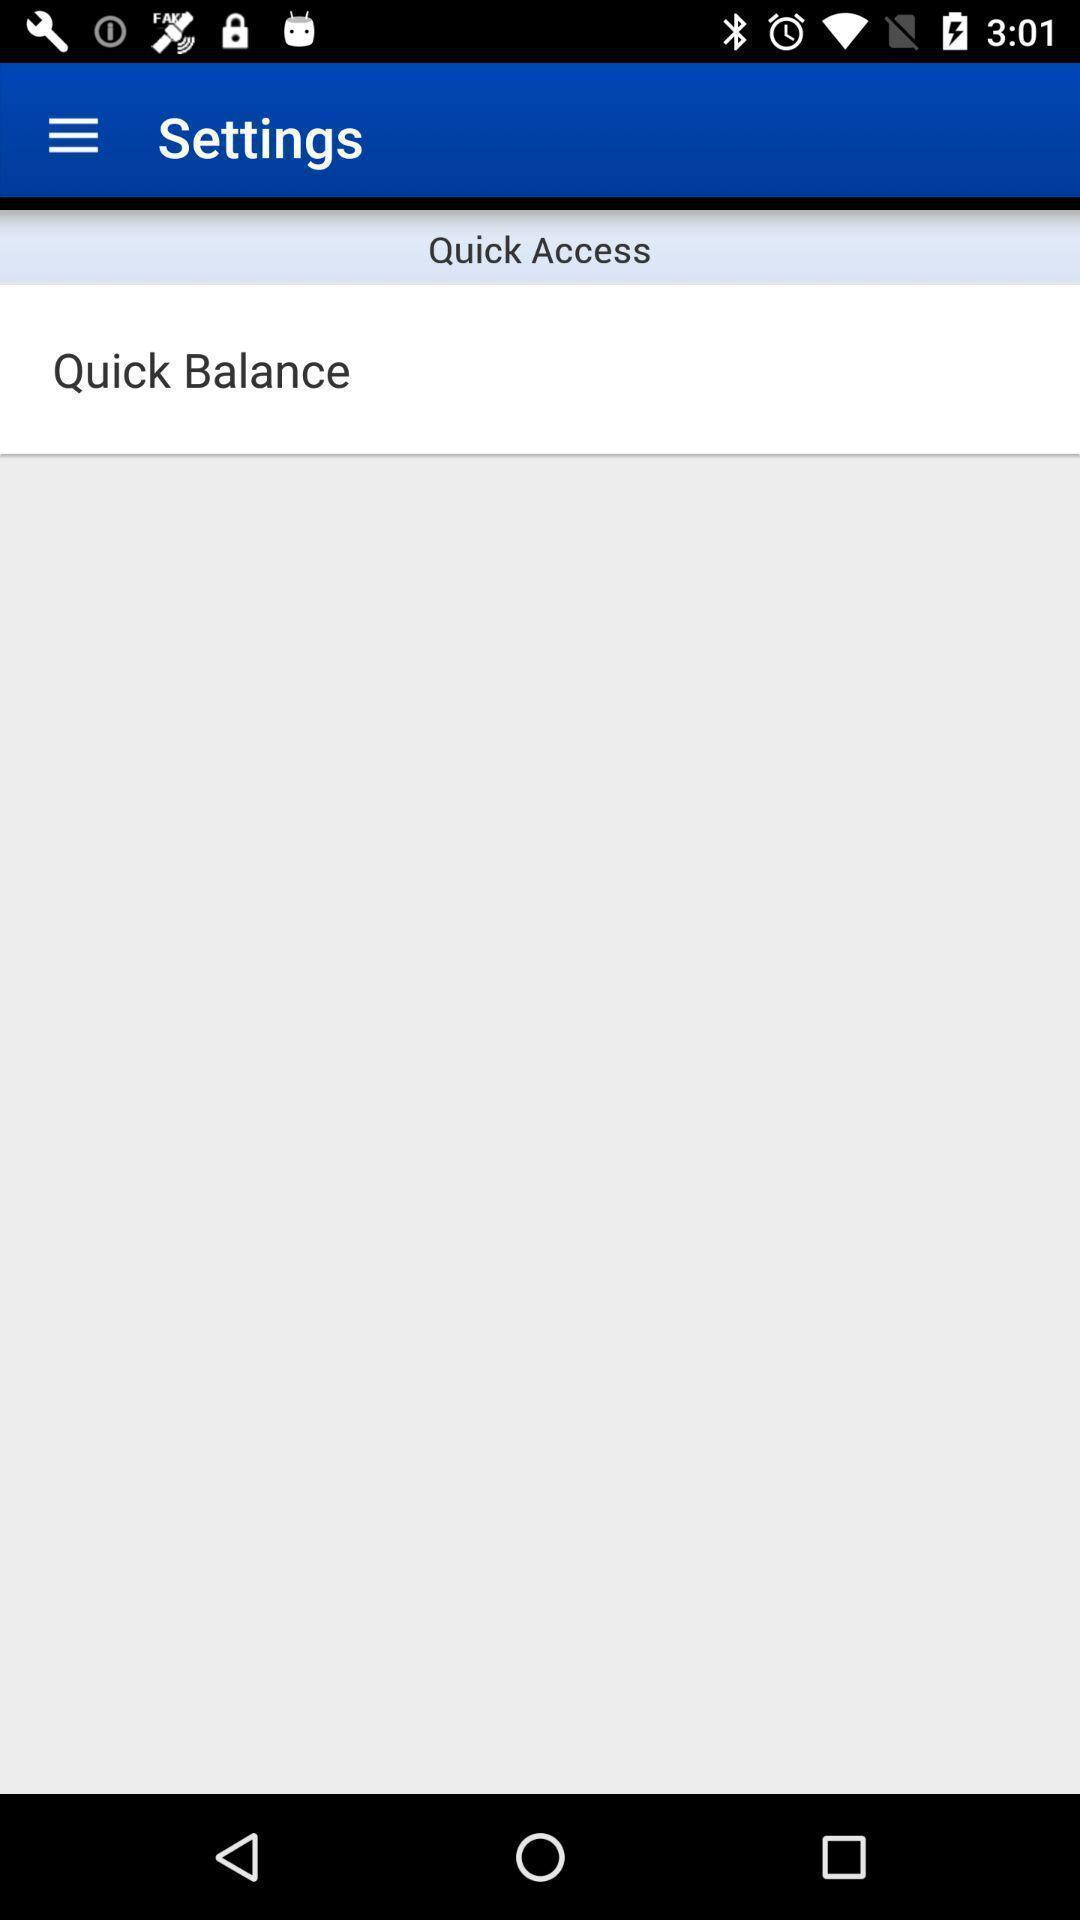Provide a description of this screenshot. Settings page with an option in the application. 